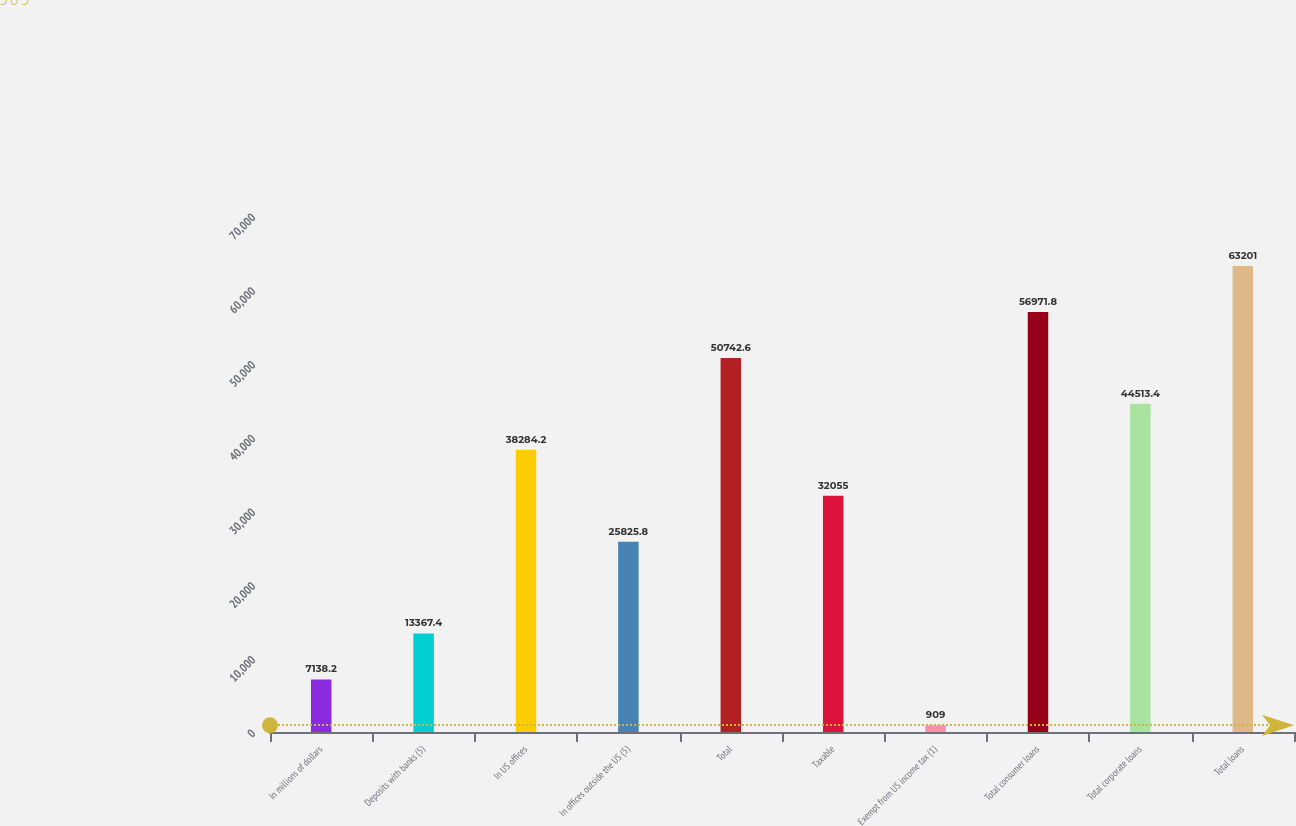Convert chart. <chart><loc_0><loc_0><loc_500><loc_500><bar_chart><fcel>In millions of dollars<fcel>Deposits with banks (5)<fcel>In US offices<fcel>In offices outside the US (5)<fcel>Total<fcel>Taxable<fcel>Exempt from US income tax (1)<fcel>Total consumer loans<fcel>Total corporate loans<fcel>Total loans<nl><fcel>7138.2<fcel>13367.4<fcel>38284.2<fcel>25825.8<fcel>50742.6<fcel>32055<fcel>909<fcel>56971.8<fcel>44513.4<fcel>63201<nl></chart> 